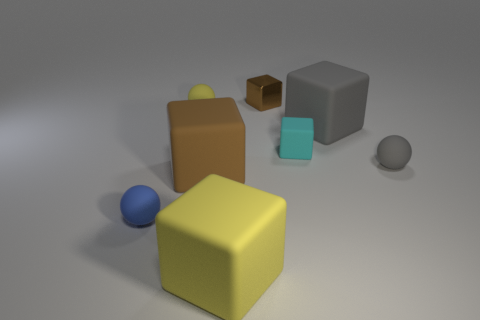Is the number of tiny metallic objects in front of the small brown shiny thing greater than the number of tiny blue balls?
Keep it short and to the point. No. There is a brown shiny object; is it the same shape as the yellow object right of the yellow matte sphere?
Ensure brevity in your answer.  Yes. How many green matte cubes are the same size as the gray ball?
Keep it short and to the point. 0. How many tiny cyan matte things are on the right side of the rubber sphere that is to the right of the cyan object behind the big yellow matte object?
Provide a short and direct response. 0. Are there an equal number of tiny blue balls right of the cyan matte object and yellow cubes right of the big yellow block?
Your answer should be compact. Yes. What number of cyan rubber things are the same shape as the small yellow matte object?
Your answer should be very brief. 0. Is there a purple object made of the same material as the small blue thing?
Offer a very short reply. No. What shape is the large rubber object that is the same color as the small metal object?
Give a very brief answer. Cube. What number of large yellow objects are there?
Provide a short and direct response. 1. What number of spheres are either small yellow rubber things or gray objects?
Your answer should be compact. 2. 